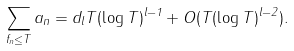<formula> <loc_0><loc_0><loc_500><loc_500>\sum _ { f _ { n } \leq T } a _ { n } = d _ { l } T ( \log T ) ^ { l - 1 } + O ( T ( \log T ) ^ { l - 2 } ) .</formula> 